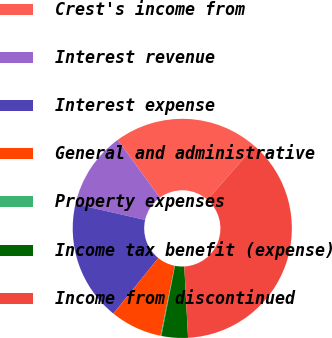Convert chart. <chart><loc_0><loc_0><loc_500><loc_500><pie_chart><fcel>Crest's income from<fcel>Interest revenue<fcel>Interest expense<fcel>General and administrative<fcel>Property expenses<fcel>Income tax benefit (expense)<fcel>Income from discontinued<nl><fcel>21.5%<fcel>11.4%<fcel>17.74%<fcel>7.64%<fcel>0.13%<fcel>3.89%<fcel>37.7%<nl></chart> 